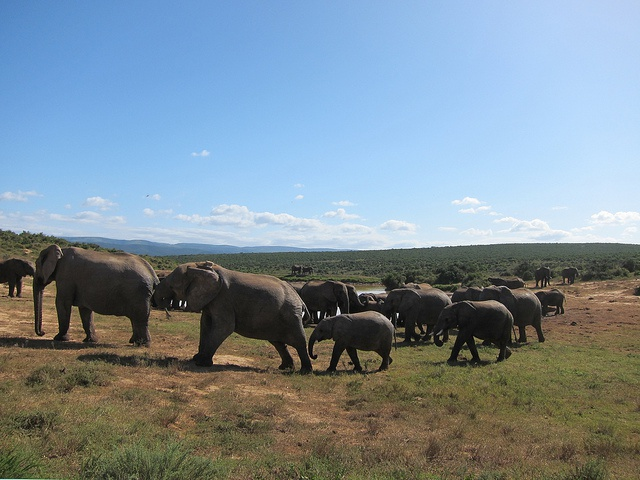Describe the objects in this image and their specific colors. I can see elephant in gray and black tones, elephant in gray, black, and tan tones, elephant in gray and black tones, elephant in gray, black, and darkgray tones, and elephant in gray, black, and darkgray tones in this image. 